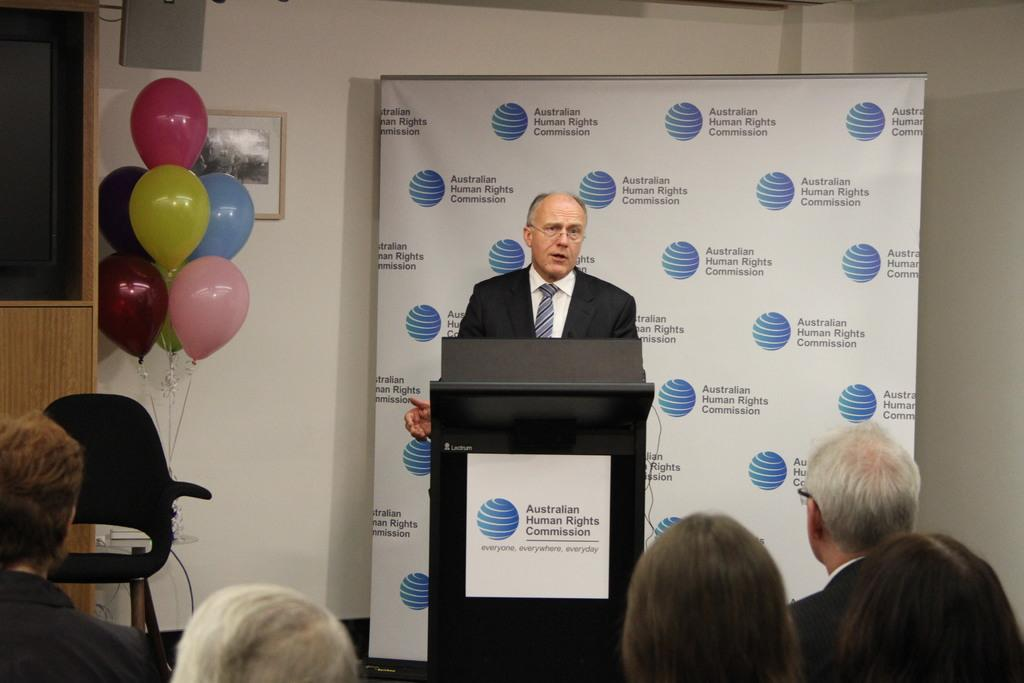Provide a one-sentence caption for the provided image. A man standing behind the Australian human rights commission podium. 